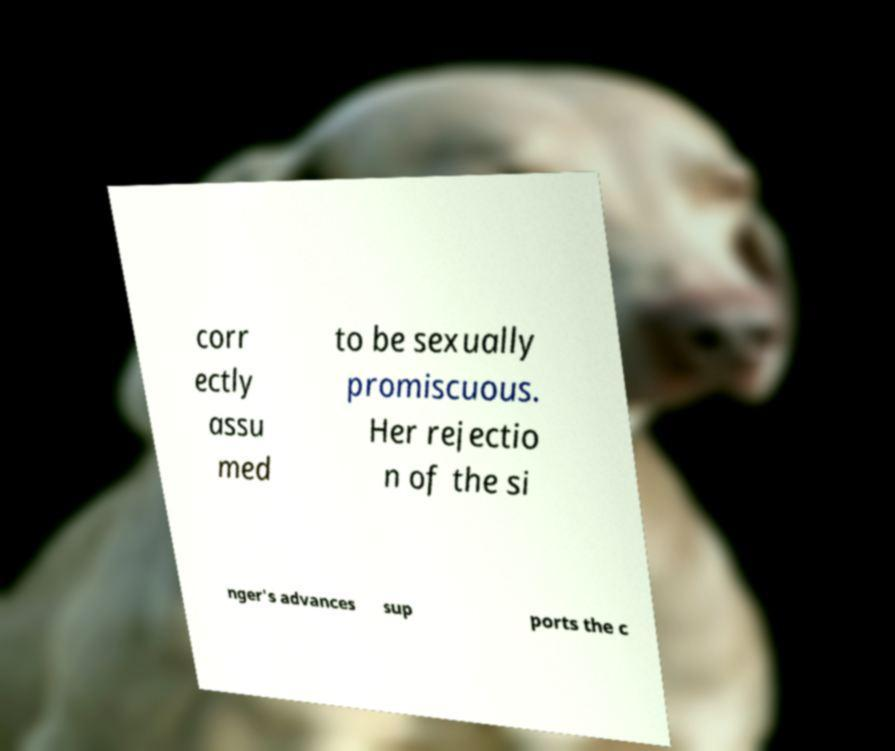Could you extract and type out the text from this image? corr ectly assu med to be sexually promiscuous. Her rejectio n of the si nger's advances sup ports the c 